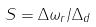Convert formula to latex. <formula><loc_0><loc_0><loc_500><loc_500>S = \Delta \omega _ { r } / \Delta _ { d }</formula> 